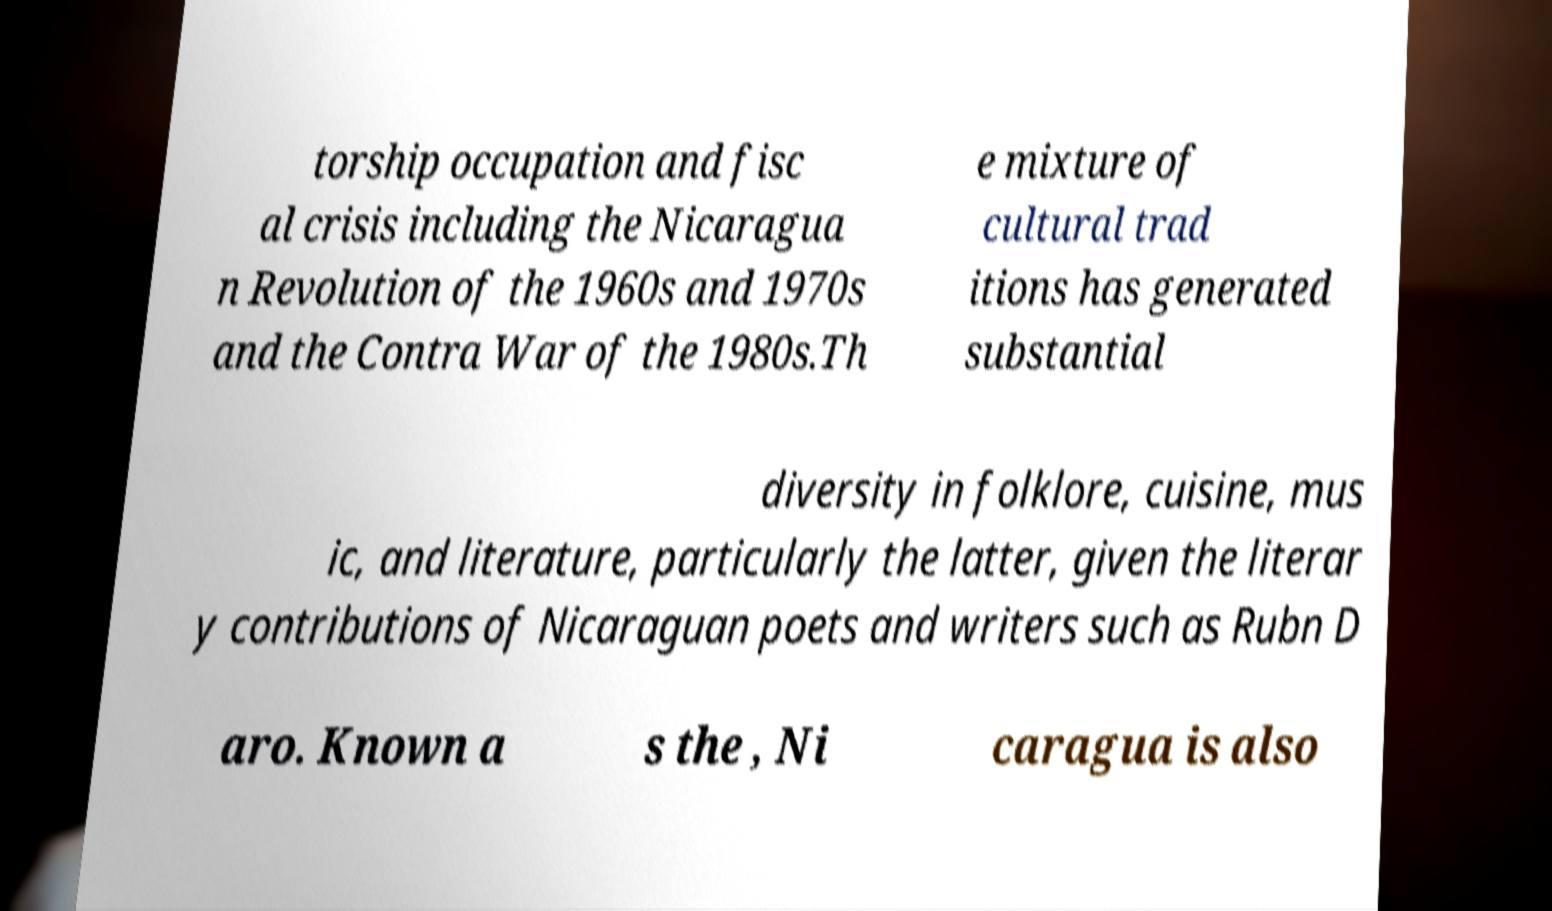For documentation purposes, I need the text within this image transcribed. Could you provide that? torship occupation and fisc al crisis including the Nicaragua n Revolution of the 1960s and 1970s and the Contra War of the 1980s.Th e mixture of cultural trad itions has generated substantial diversity in folklore, cuisine, mus ic, and literature, particularly the latter, given the literar y contributions of Nicaraguan poets and writers such as Rubn D aro. Known a s the , Ni caragua is also 